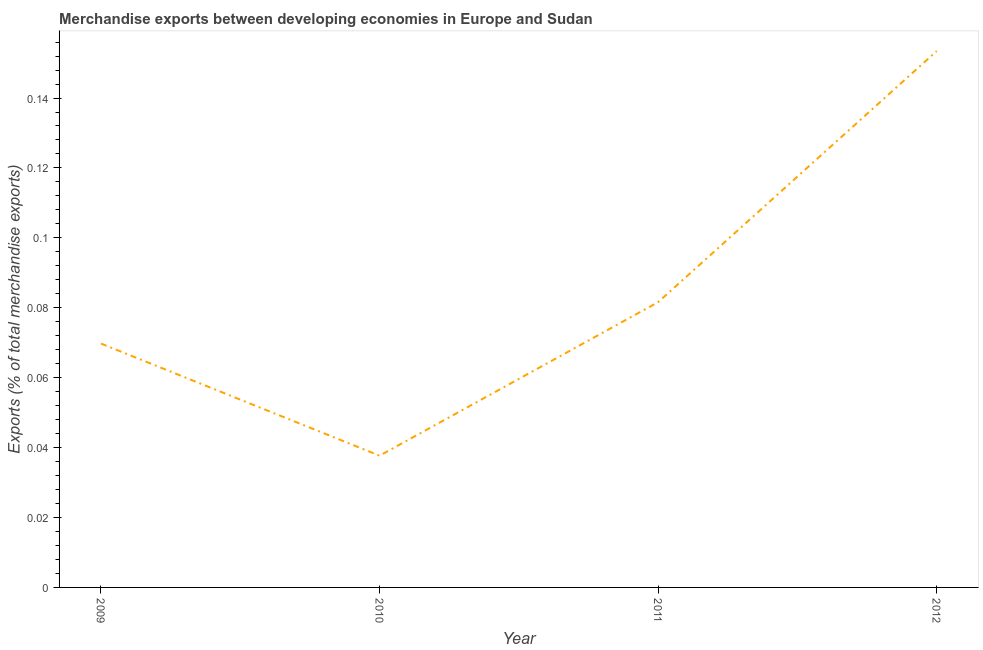What is the merchandise exports in 2010?
Give a very brief answer. 0.04. Across all years, what is the maximum merchandise exports?
Your response must be concise. 0.15. Across all years, what is the minimum merchandise exports?
Your response must be concise. 0.04. In which year was the merchandise exports minimum?
Your answer should be compact. 2010. What is the sum of the merchandise exports?
Your response must be concise. 0.34. What is the difference between the merchandise exports in 2009 and 2011?
Ensure brevity in your answer.  -0.01. What is the average merchandise exports per year?
Offer a very short reply. 0.09. What is the median merchandise exports?
Provide a succinct answer. 0.08. In how many years, is the merchandise exports greater than 0.048 %?
Your answer should be compact. 3. Do a majority of the years between 2010 and 2011 (inclusive) have merchandise exports greater than 0.088 %?
Provide a short and direct response. No. What is the ratio of the merchandise exports in 2010 to that in 2011?
Offer a terse response. 0.46. Is the difference between the merchandise exports in 2009 and 2012 greater than the difference between any two years?
Provide a short and direct response. No. What is the difference between the highest and the second highest merchandise exports?
Offer a very short reply. 0.07. Is the sum of the merchandise exports in 2009 and 2010 greater than the maximum merchandise exports across all years?
Offer a very short reply. No. What is the difference between the highest and the lowest merchandise exports?
Your answer should be compact. 0.12. How many years are there in the graph?
Offer a very short reply. 4. Are the values on the major ticks of Y-axis written in scientific E-notation?
Offer a very short reply. No. Does the graph contain grids?
Provide a short and direct response. No. What is the title of the graph?
Keep it short and to the point. Merchandise exports between developing economies in Europe and Sudan. What is the label or title of the Y-axis?
Provide a succinct answer. Exports (% of total merchandise exports). What is the Exports (% of total merchandise exports) of 2009?
Provide a succinct answer. 0.07. What is the Exports (% of total merchandise exports) of 2010?
Your response must be concise. 0.04. What is the Exports (% of total merchandise exports) of 2011?
Ensure brevity in your answer.  0.08. What is the Exports (% of total merchandise exports) in 2012?
Give a very brief answer. 0.15. What is the difference between the Exports (% of total merchandise exports) in 2009 and 2010?
Offer a very short reply. 0.03. What is the difference between the Exports (% of total merchandise exports) in 2009 and 2011?
Make the answer very short. -0.01. What is the difference between the Exports (% of total merchandise exports) in 2009 and 2012?
Keep it short and to the point. -0.08. What is the difference between the Exports (% of total merchandise exports) in 2010 and 2011?
Provide a succinct answer. -0.04. What is the difference between the Exports (% of total merchandise exports) in 2010 and 2012?
Offer a very short reply. -0.12. What is the difference between the Exports (% of total merchandise exports) in 2011 and 2012?
Offer a terse response. -0.07. What is the ratio of the Exports (% of total merchandise exports) in 2009 to that in 2010?
Provide a succinct answer. 1.85. What is the ratio of the Exports (% of total merchandise exports) in 2009 to that in 2011?
Your answer should be very brief. 0.85. What is the ratio of the Exports (% of total merchandise exports) in 2009 to that in 2012?
Give a very brief answer. 0.46. What is the ratio of the Exports (% of total merchandise exports) in 2010 to that in 2011?
Provide a succinct answer. 0.46. What is the ratio of the Exports (% of total merchandise exports) in 2010 to that in 2012?
Your answer should be very brief. 0.25. What is the ratio of the Exports (% of total merchandise exports) in 2011 to that in 2012?
Provide a short and direct response. 0.53. 